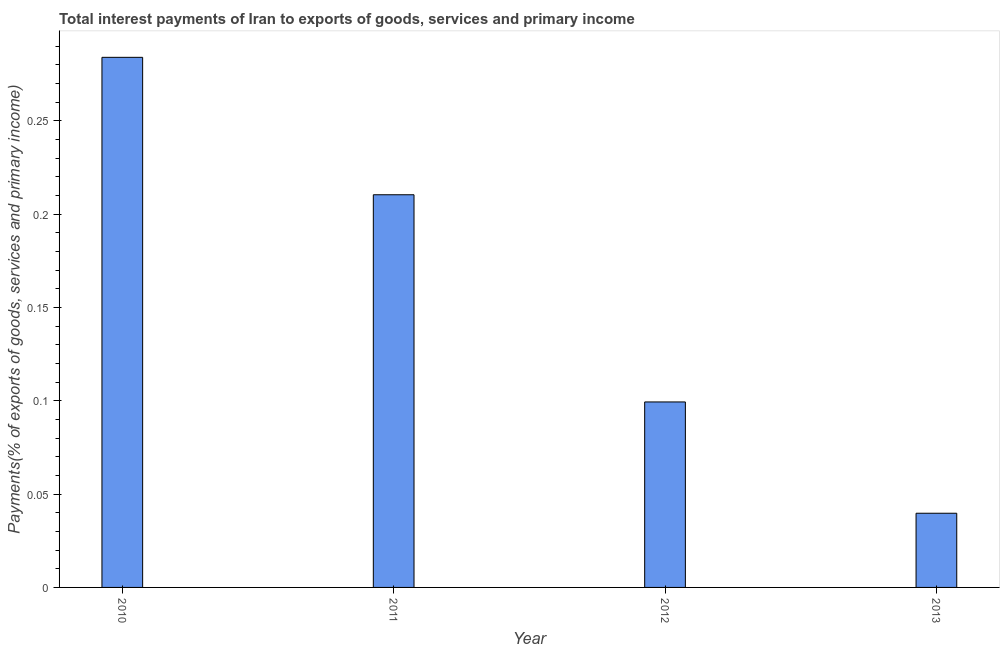Does the graph contain grids?
Provide a succinct answer. No. What is the title of the graph?
Provide a succinct answer. Total interest payments of Iran to exports of goods, services and primary income. What is the label or title of the Y-axis?
Give a very brief answer. Payments(% of exports of goods, services and primary income). What is the total interest payments on external debt in 2010?
Your response must be concise. 0.28. Across all years, what is the maximum total interest payments on external debt?
Provide a short and direct response. 0.28. Across all years, what is the minimum total interest payments on external debt?
Provide a succinct answer. 0.04. What is the sum of the total interest payments on external debt?
Give a very brief answer. 0.63. What is the difference between the total interest payments on external debt in 2010 and 2012?
Offer a terse response. 0.18. What is the average total interest payments on external debt per year?
Provide a succinct answer. 0.16. What is the median total interest payments on external debt?
Your answer should be very brief. 0.15. What is the ratio of the total interest payments on external debt in 2010 to that in 2013?
Ensure brevity in your answer.  7.15. What is the difference between the highest and the second highest total interest payments on external debt?
Provide a short and direct response. 0.07. Is the sum of the total interest payments on external debt in 2010 and 2011 greater than the maximum total interest payments on external debt across all years?
Your answer should be compact. Yes. What is the difference between the highest and the lowest total interest payments on external debt?
Provide a short and direct response. 0.24. In how many years, is the total interest payments on external debt greater than the average total interest payments on external debt taken over all years?
Keep it short and to the point. 2. How many years are there in the graph?
Keep it short and to the point. 4. What is the difference between two consecutive major ticks on the Y-axis?
Give a very brief answer. 0.05. What is the Payments(% of exports of goods, services and primary income) of 2010?
Offer a very short reply. 0.28. What is the Payments(% of exports of goods, services and primary income) in 2011?
Provide a short and direct response. 0.21. What is the Payments(% of exports of goods, services and primary income) of 2012?
Your response must be concise. 0.1. What is the Payments(% of exports of goods, services and primary income) of 2013?
Provide a short and direct response. 0.04. What is the difference between the Payments(% of exports of goods, services and primary income) in 2010 and 2011?
Provide a succinct answer. 0.07. What is the difference between the Payments(% of exports of goods, services and primary income) in 2010 and 2012?
Your response must be concise. 0.18. What is the difference between the Payments(% of exports of goods, services and primary income) in 2010 and 2013?
Your response must be concise. 0.24. What is the difference between the Payments(% of exports of goods, services and primary income) in 2011 and 2012?
Keep it short and to the point. 0.11. What is the difference between the Payments(% of exports of goods, services and primary income) in 2011 and 2013?
Offer a terse response. 0.17. What is the difference between the Payments(% of exports of goods, services and primary income) in 2012 and 2013?
Provide a succinct answer. 0.06. What is the ratio of the Payments(% of exports of goods, services and primary income) in 2010 to that in 2011?
Give a very brief answer. 1.35. What is the ratio of the Payments(% of exports of goods, services and primary income) in 2010 to that in 2012?
Your answer should be compact. 2.86. What is the ratio of the Payments(% of exports of goods, services and primary income) in 2010 to that in 2013?
Ensure brevity in your answer.  7.15. What is the ratio of the Payments(% of exports of goods, services and primary income) in 2011 to that in 2012?
Offer a very short reply. 2.12. What is the ratio of the Payments(% of exports of goods, services and primary income) in 2011 to that in 2013?
Offer a terse response. 5.29. What is the ratio of the Payments(% of exports of goods, services and primary income) in 2012 to that in 2013?
Your answer should be compact. 2.5. 